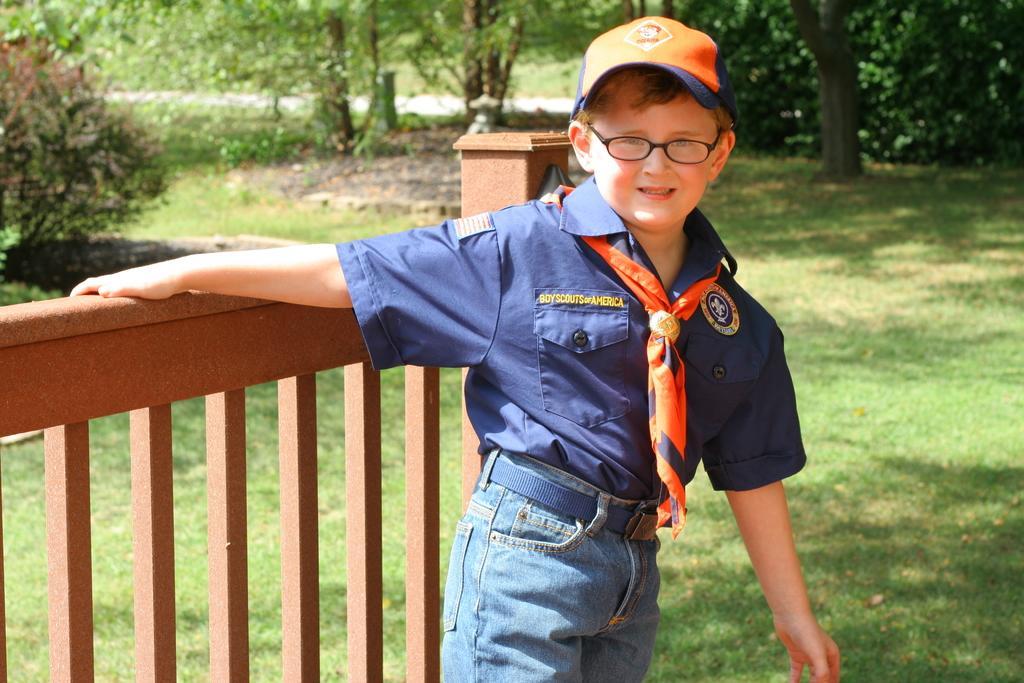Describe this image in one or two sentences. In this picture there is a boy standing, behind this boy we can see railing. In the background of the image we can see grass, trees and plants. 